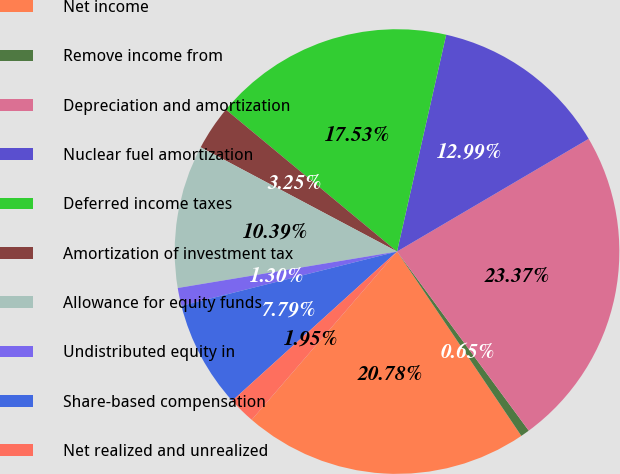Convert chart to OTSL. <chart><loc_0><loc_0><loc_500><loc_500><pie_chart><fcel>Net income<fcel>Remove income from<fcel>Depreciation and amortization<fcel>Nuclear fuel amortization<fcel>Deferred income taxes<fcel>Amortization of investment tax<fcel>Allowance for equity funds<fcel>Undistributed equity in<fcel>Share-based compensation<fcel>Net realized and unrealized<nl><fcel>20.78%<fcel>0.65%<fcel>23.37%<fcel>12.99%<fcel>17.53%<fcel>3.25%<fcel>10.39%<fcel>1.3%<fcel>7.79%<fcel>1.95%<nl></chart> 